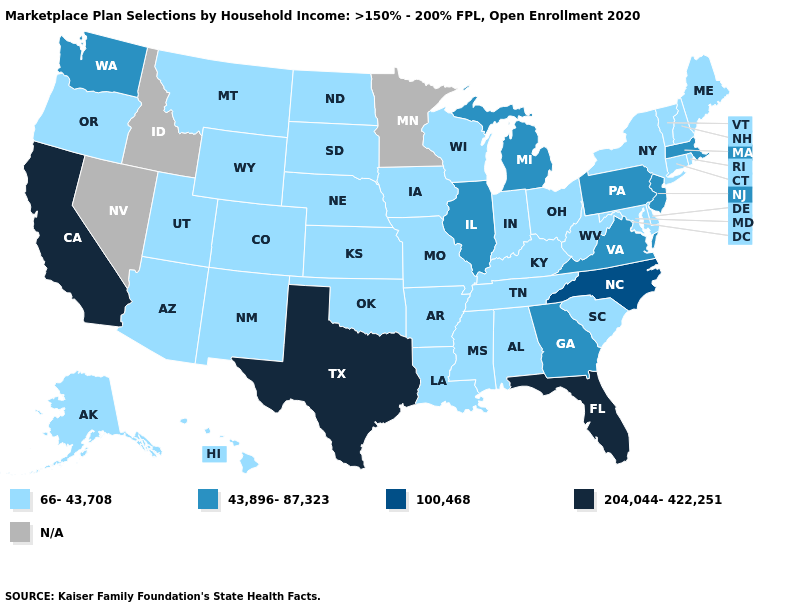What is the value of Georgia?
Answer briefly. 43,896-87,323. Name the states that have a value in the range N/A?
Answer briefly. Idaho, Minnesota, Nevada. Is the legend a continuous bar?
Be succinct. No. Among the states that border Arizona , which have the highest value?
Answer briefly. California. Which states have the lowest value in the USA?
Concise answer only. Alabama, Alaska, Arizona, Arkansas, Colorado, Connecticut, Delaware, Hawaii, Indiana, Iowa, Kansas, Kentucky, Louisiana, Maine, Maryland, Mississippi, Missouri, Montana, Nebraska, New Hampshire, New Mexico, New York, North Dakota, Ohio, Oklahoma, Oregon, Rhode Island, South Carolina, South Dakota, Tennessee, Utah, Vermont, West Virginia, Wisconsin, Wyoming. Does Massachusetts have the lowest value in the Northeast?
Concise answer only. No. Does Montana have the lowest value in the USA?
Concise answer only. Yes. What is the value of Missouri?
Write a very short answer. 66-43,708. Which states have the lowest value in the South?
Be succinct. Alabama, Arkansas, Delaware, Kentucky, Louisiana, Maryland, Mississippi, Oklahoma, South Carolina, Tennessee, West Virginia. Does Illinois have the lowest value in the MidWest?
Keep it brief. No. Name the states that have a value in the range 66-43,708?
Write a very short answer. Alabama, Alaska, Arizona, Arkansas, Colorado, Connecticut, Delaware, Hawaii, Indiana, Iowa, Kansas, Kentucky, Louisiana, Maine, Maryland, Mississippi, Missouri, Montana, Nebraska, New Hampshire, New Mexico, New York, North Dakota, Ohio, Oklahoma, Oregon, Rhode Island, South Carolina, South Dakota, Tennessee, Utah, Vermont, West Virginia, Wisconsin, Wyoming. What is the value of Idaho?
Concise answer only. N/A. Is the legend a continuous bar?
Be succinct. No. 